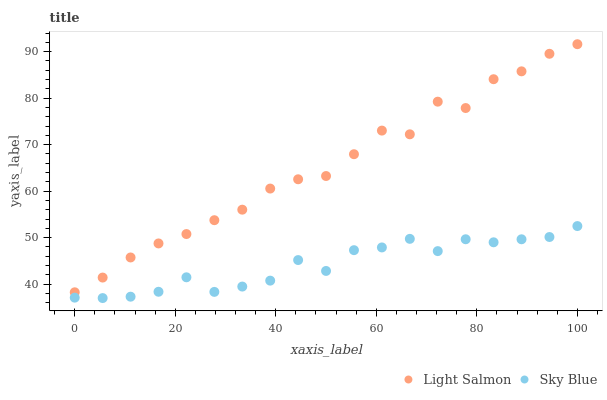Does Sky Blue have the minimum area under the curve?
Answer yes or no. Yes. Does Light Salmon have the maximum area under the curve?
Answer yes or no. Yes. Does Light Salmon have the minimum area under the curve?
Answer yes or no. No. Is Sky Blue the smoothest?
Answer yes or no. Yes. Is Light Salmon the roughest?
Answer yes or no. Yes. Is Light Salmon the smoothest?
Answer yes or no. No. Does Sky Blue have the lowest value?
Answer yes or no. Yes. Does Light Salmon have the lowest value?
Answer yes or no. No. Does Light Salmon have the highest value?
Answer yes or no. Yes. Is Sky Blue less than Light Salmon?
Answer yes or no. Yes. Is Light Salmon greater than Sky Blue?
Answer yes or no. Yes. Does Sky Blue intersect Light Salmon?
Answer yes or no. No. 